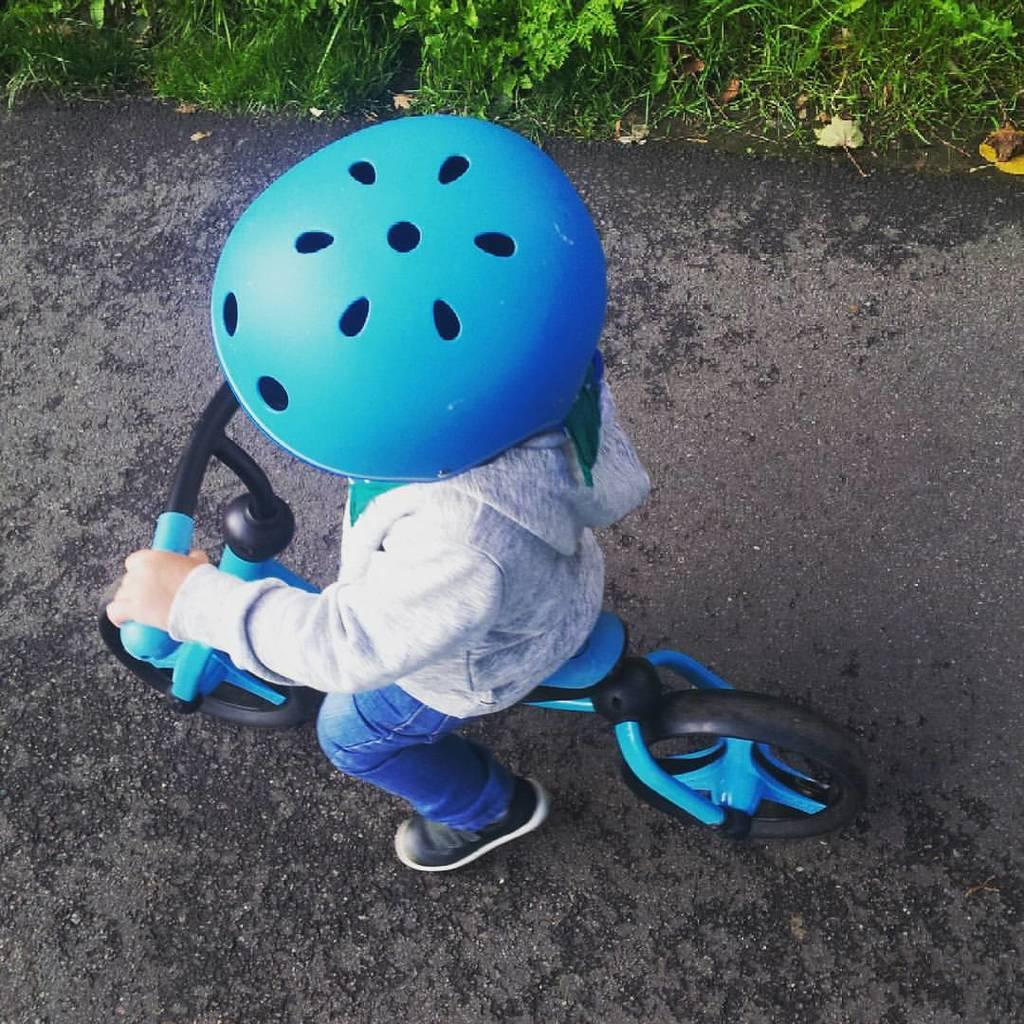What is the main subject of the image? The main subject of the image is a kid. What is the kid doing in the image? The kid is sitting on a bicycle. Is the kid wearing any safety gear in the image? Yes, the kid is wearing a helmet. Where is the bicycle located in the image? The bicycle is on the road. What can be seen in the background of the image? There is grass and shredded leaves in the background of the image. Can you see any cherries on the bicycle in the image? There are no cherries present on the bicycle or in the image. Is the kid's family visible in the image? The image only shows the kid and the bicycle, so there is no indication of the kid's family being present. 